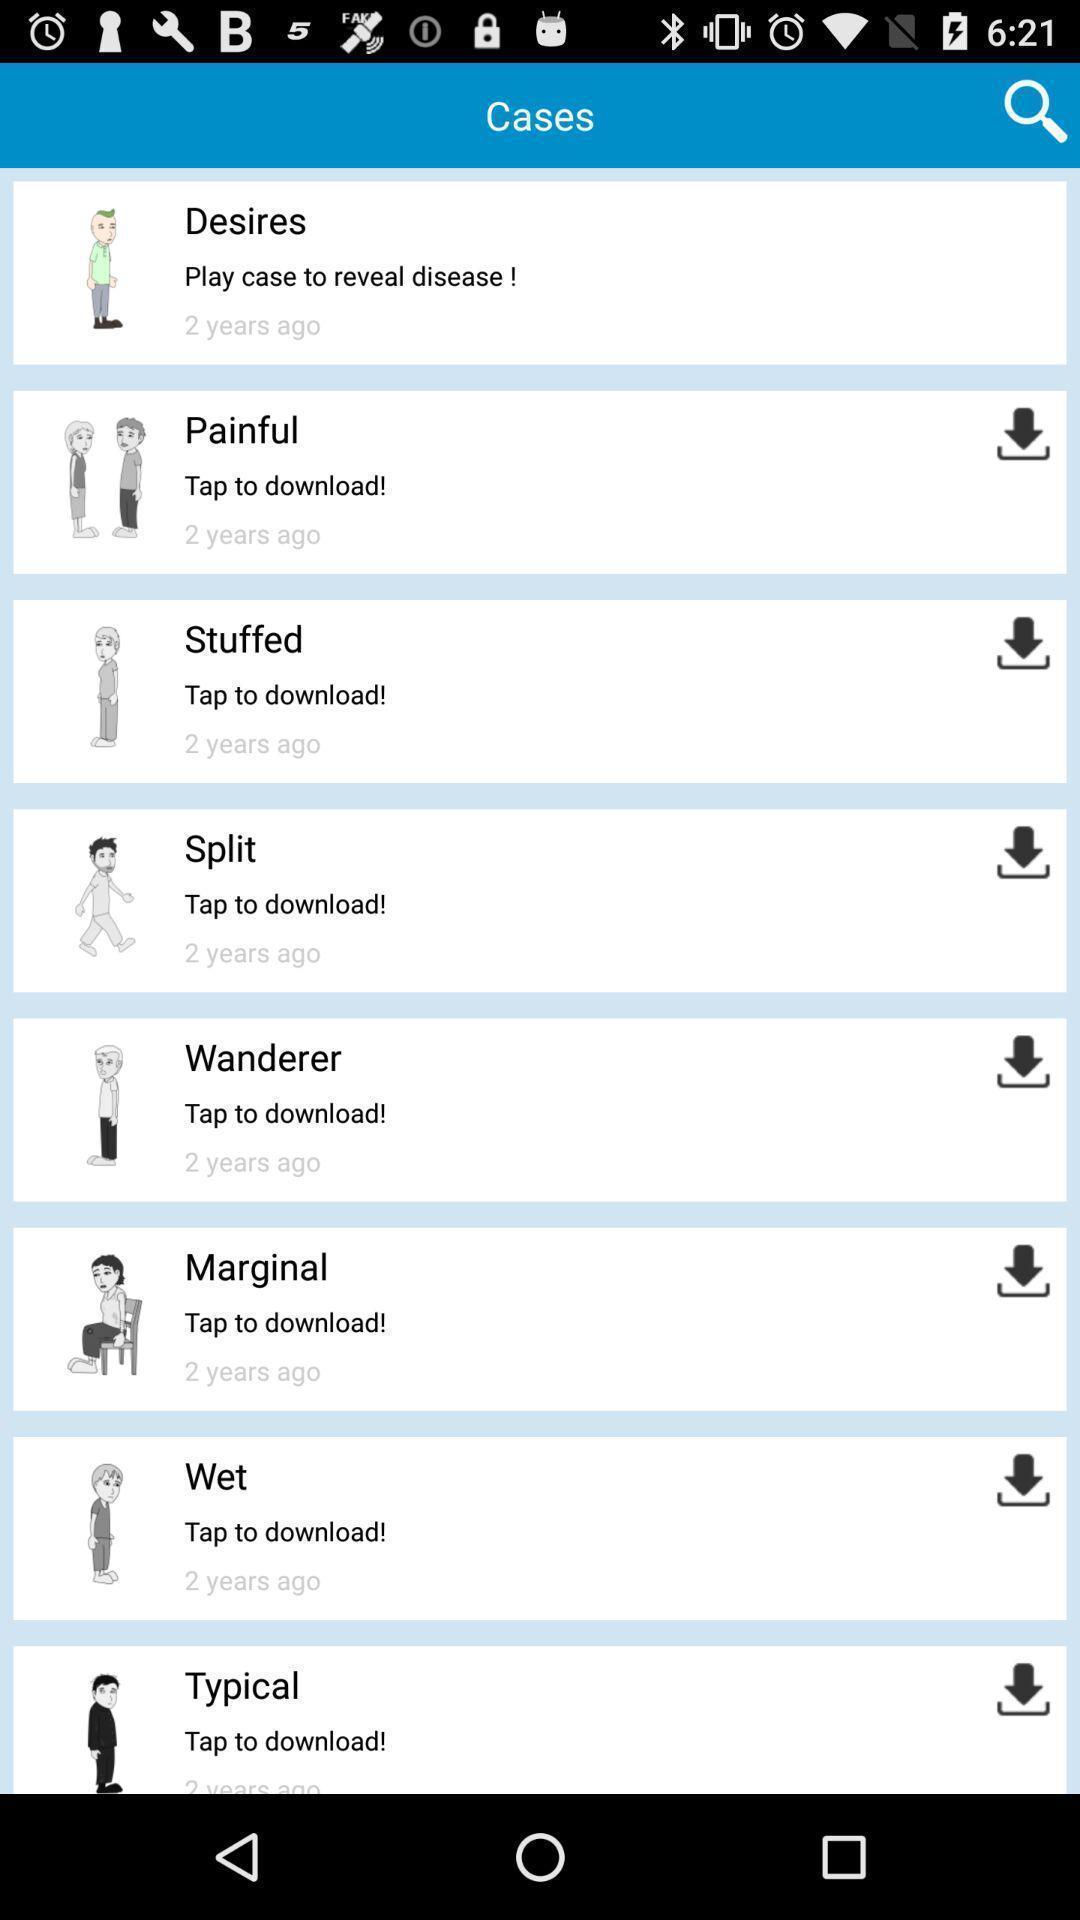Provide a textual representation of this image. Page showing list of options. 